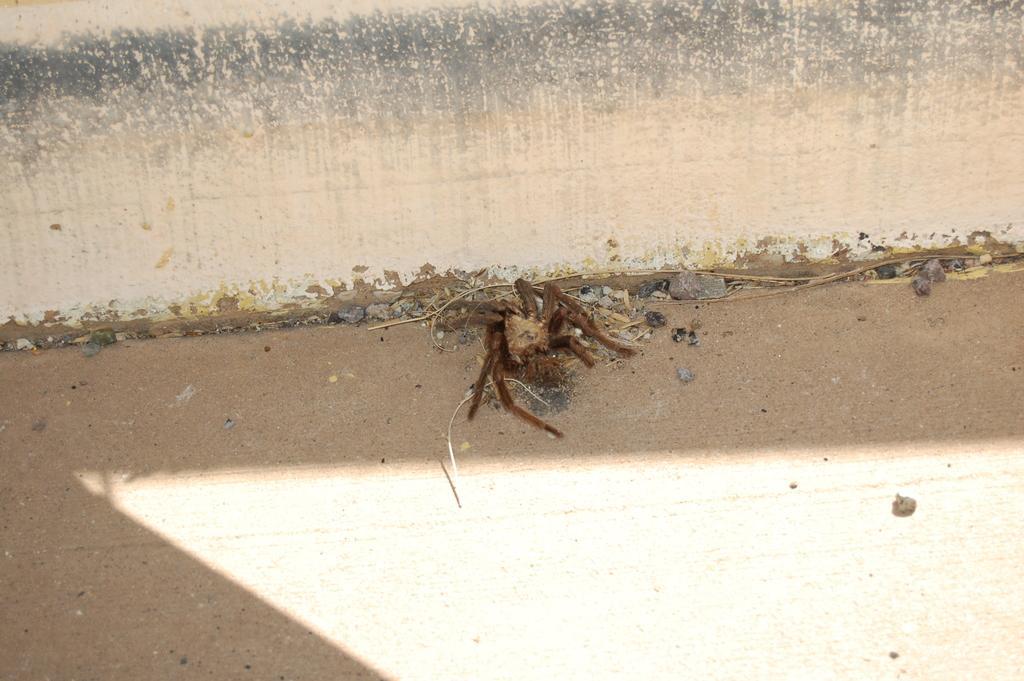Can you describe this image briefly? In this image I can see the ground, an insect which is brown and cream in color, the cream and black colored surface and few small stones. 